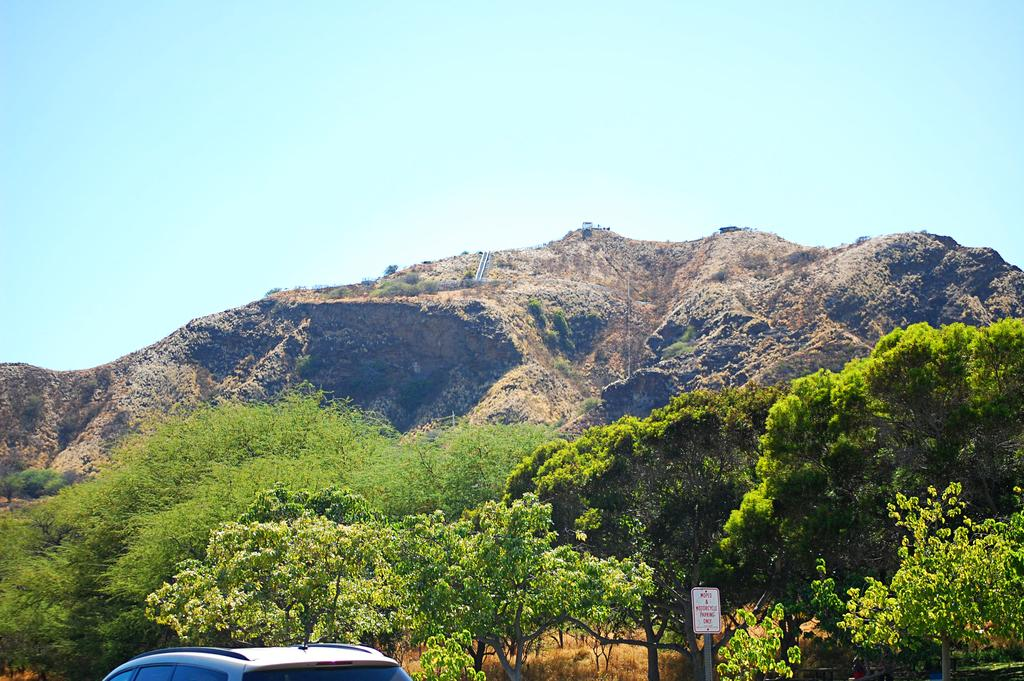Where was the image taken? The image is clicked outside. What can be seen at the bottom of the image? There are trees and a car at the bottom of the image. What is visible at the top of the image? There is sky visible at the top of the image. What type of landscape feature is present in the middle of the image? There are hills in the middle of the image. What type of silk is draped over the trees in the image? There is no silk present in the image; it features trees, a car, hills, and sky. Can you describe the aftermath of the skate accident in the image? There is no skate accident or any reference to skating in the image. 